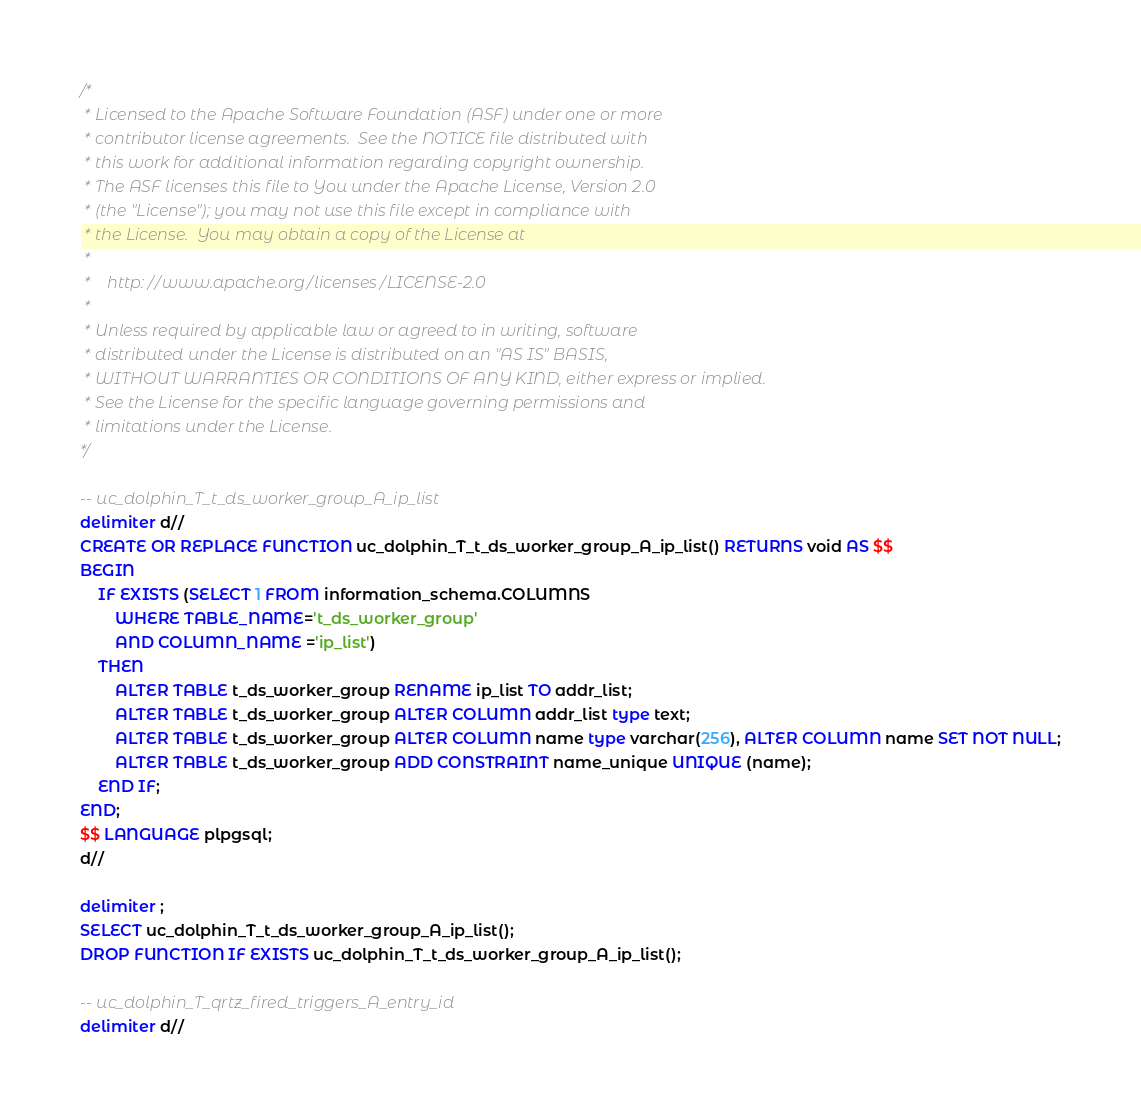<code> <loc_0><loc_0><loc_500><loc_500><_SQL_>/*
 * Licensed to the Apache Software Foundation (ASF) under one or more
 * contributor license agreements.  See the NOTICE file distributed with
 * this work for additional information regarding copyright ownership.
 * The ASF licenses this file to You under the Apache License, Version 2.0
 * (the "License"); you may not use this file except in compliance with
 * the License.  You may obtain a copy of the License at
 *
 *    http://www.apache.org/licenses/LICENSE-2.0
 *
 * Unless required by applicable law or agreed to in writing, software
 * distributed under the License is distributed on an "AS IS" BASIS,
 * WITHOUT WARRANTIES OR CONDITIONS OF ANY KIND, either express or implied.
 * See the License for the specific language governing permissions and
 * limitations under the License.
*/

-- uc_dolphin_T_t_ds_worker_group_A_ip_list
delimiter d//
CREATE OR REPLACE FUNCTION uc_dolphin_T_t_ds_worker_group_A_ip_list() RETURNS void AS $$
BEGIN
    IF EXISTS (SELECT 1 FROM information_schema.COLUMNS
        WHERE TABLE_NAME='t_ds_worker_group'
        AND COLUMN_NAME ='ip_list')
    THEN
        ALTER TABLE t_ds_worker_group RENAME ip_list TO addr_list;
        ALTER TABLE t_ds_worker_group ALTER COLUMN addr_list type text;
        ALTER TABLE t_ds_worker_group ALTER COLUMN name type varchar(256), ALTER COLUMN name SET NOT NULL;
        ALTER TABLE t_ds_worker_group ADD CONSTRAINT name_unique UNIQUE (name);
    END IF;
END;
$$ LANGUAGE plpgsql;
d//

delimiter ;
SELECT uc_dolphin_T_t_ds_worker_group_A_ip_list();
DROP FUNCTION IF EXISTS uc_dolphin_T_t_ds_worker_group_A_ip_list();

-- uc_dolphin_T_qrtz_fired_triggers_A_entry_id
delimiter d//</code> 